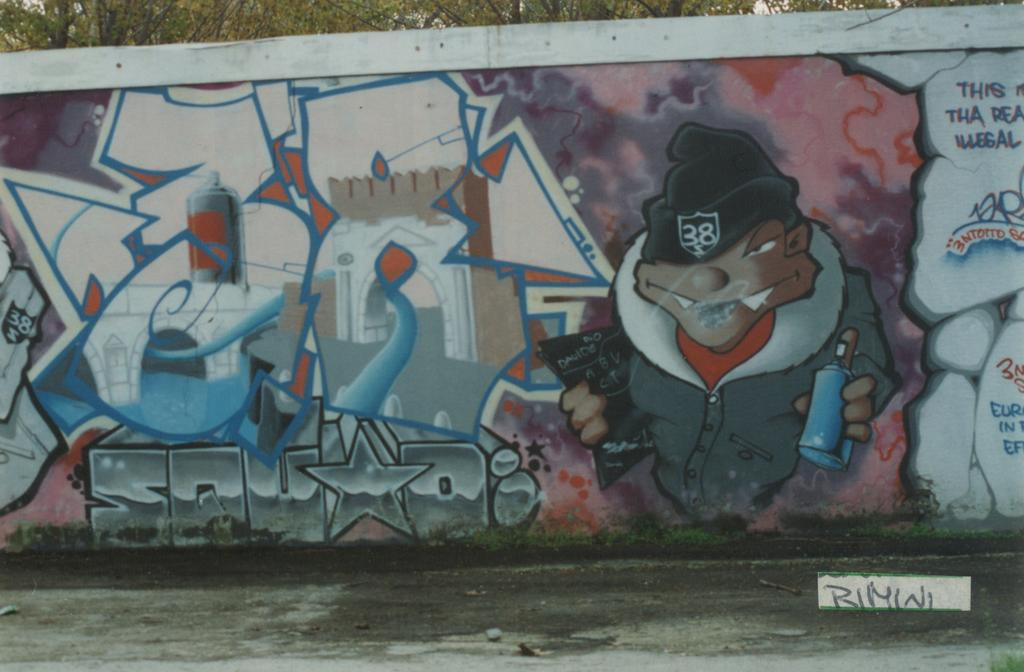What type of vegetation can be seen in the image? There is grass in the image. What structure is visible in the image? There is a wall in the image. What other natural elements are present in the image? There are trees in the image. Can you describe the wall in the image? There is a painting on the wall and something written on it. What type of beast can be seen in the sky in the image? There is no beast visible in the sky in the image. What type of stew is being prepared in the image? There is no stew being prepared in the image. 